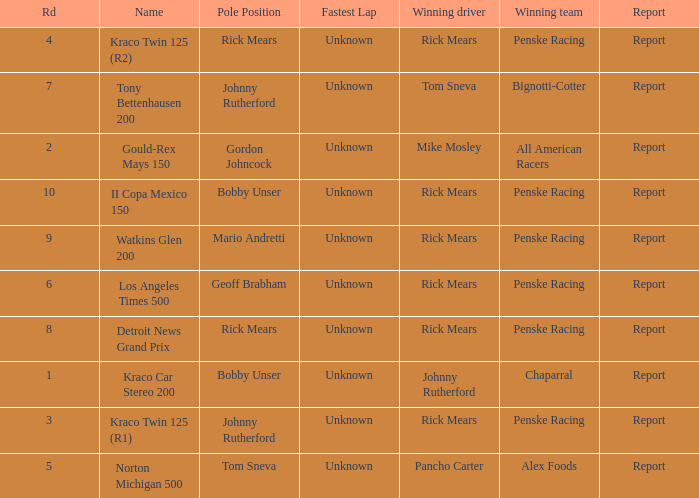How many fastest laps were there for a rd that equals 10? 1.0. 